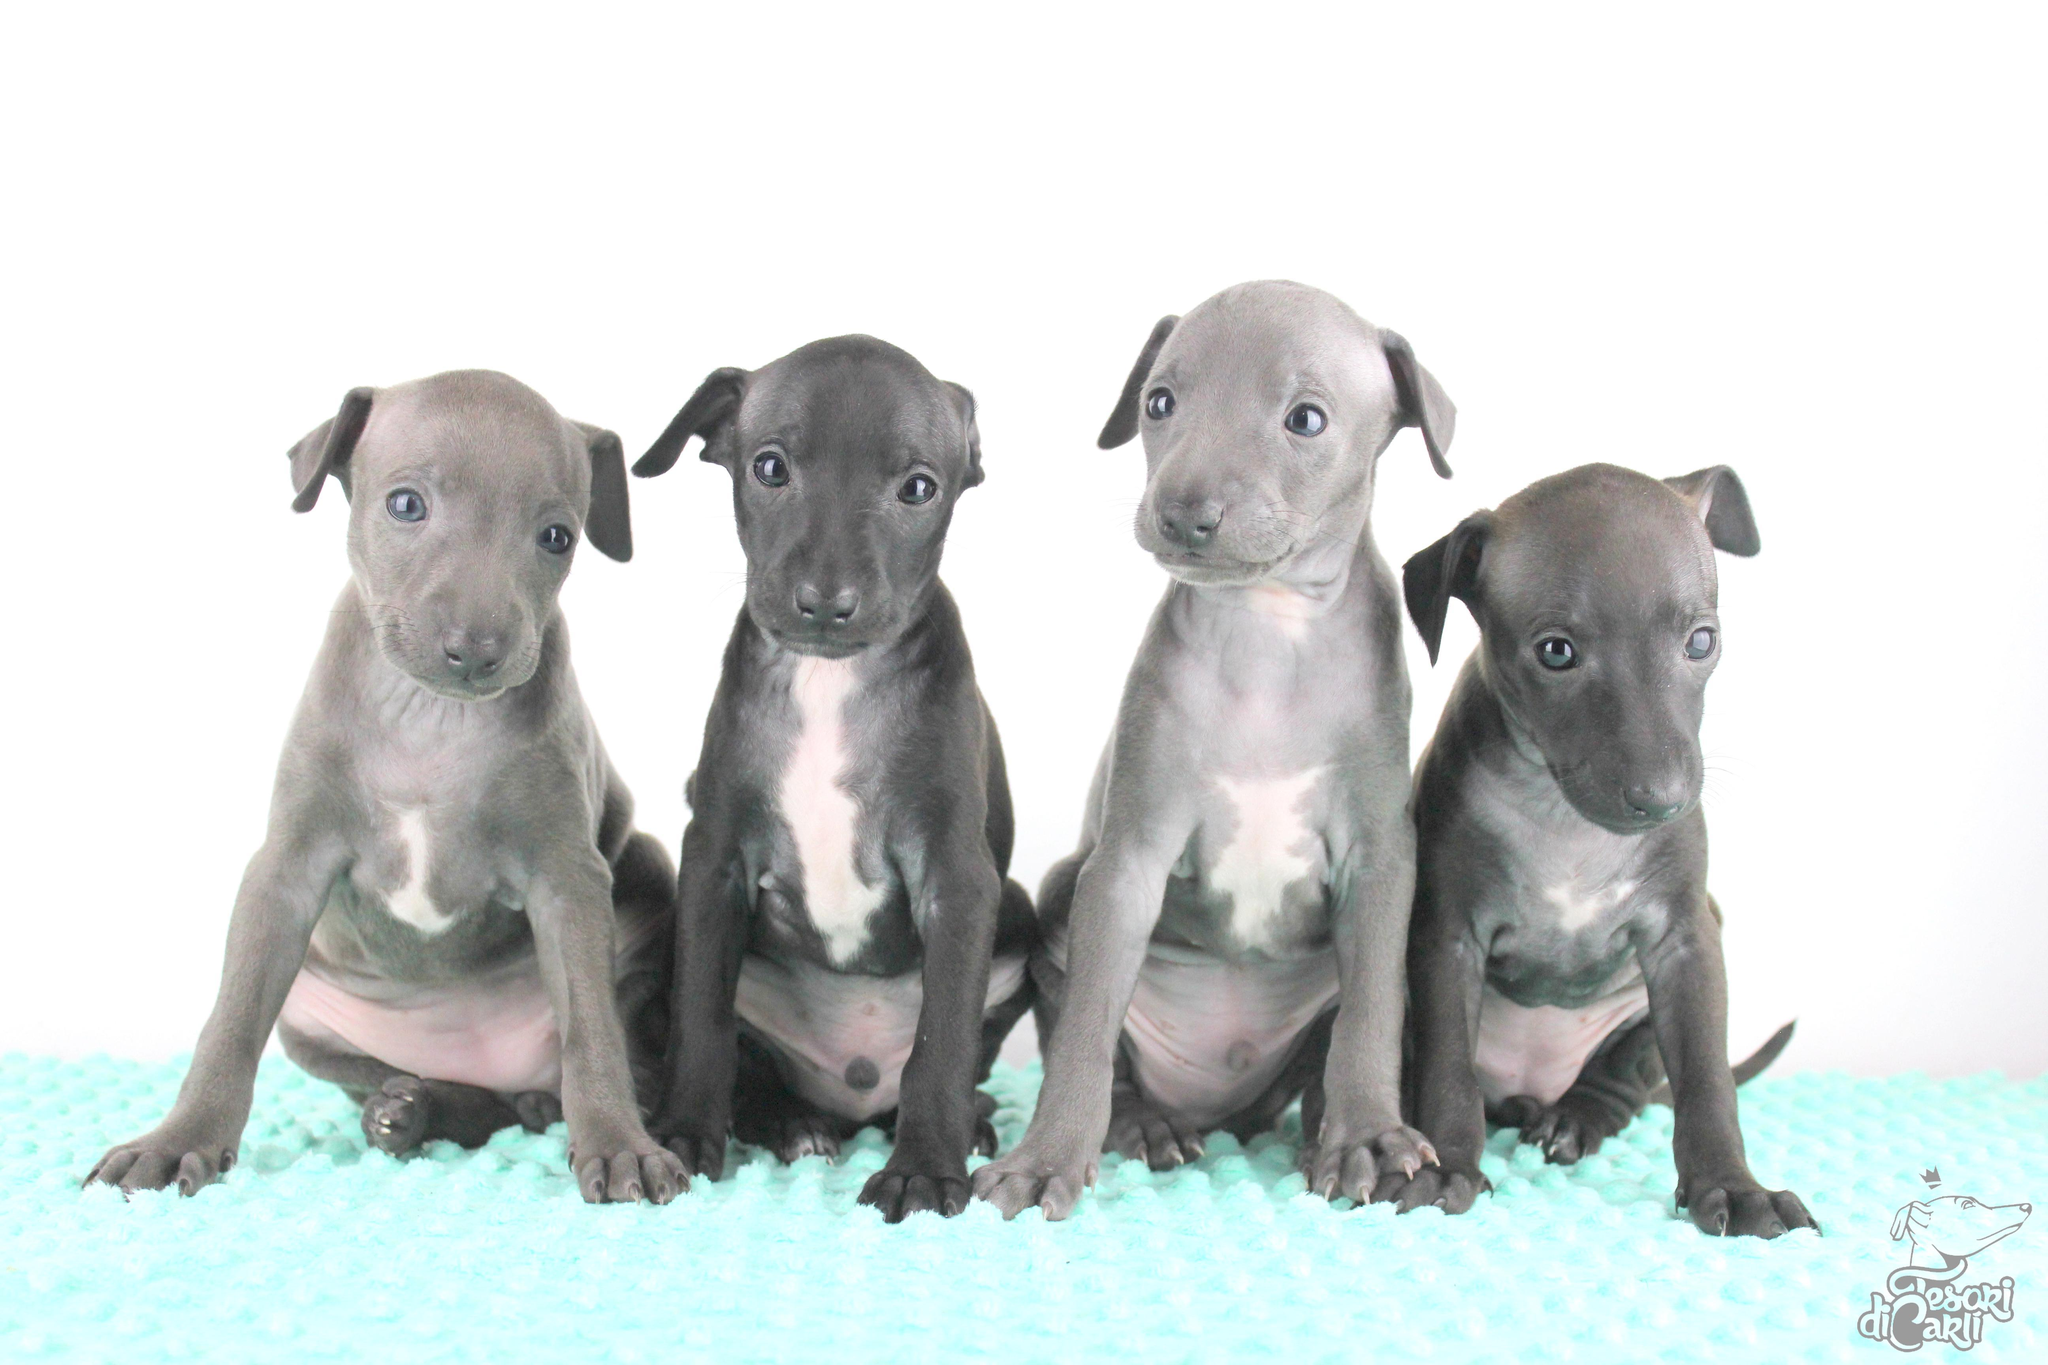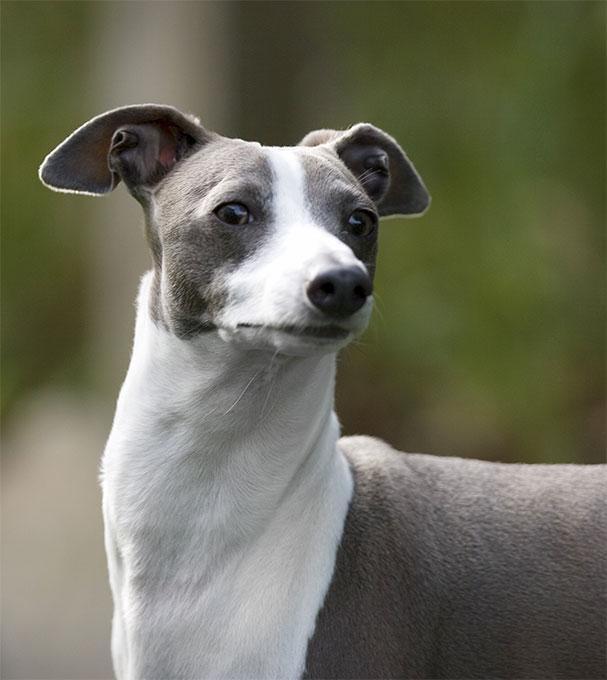The first image is the image on the left, the second image is the image on the right. Evaluate the accuracy of this statement regarding the images: "An image contains a row of at least four dogs.". Is it true? Answer yes or no. Yes. The first image is the image on the left, the second image is the image on the right. Analyze the images presented: Is the assertion "There is 1 dog standing outside." valid? Answer yes or no. Yes. 